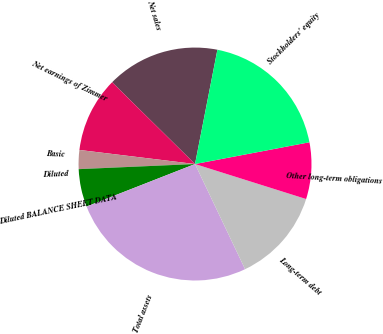<chart> <loc_0><loc_0><loc_500><loc_500><pie_chart><fcel>Net sales<fcel>Net earnings of Zimmer<fcel>Basic<fcel>Diluted<fcel>Diluted BALANCE SHEET DATA<fcel>Total assets<fcel>Long-term debt<fcel>Other long-term obligations<fcel>Stockholders' equity<nl><fcel>15.69%<fcel>10.46%<fcel>2.62%<fcel>0.01%<fcel>5.24%<fcel>26.13%<fcel>13.07%<fcel>7.85%<fcel>18.93%<nl></chart> 